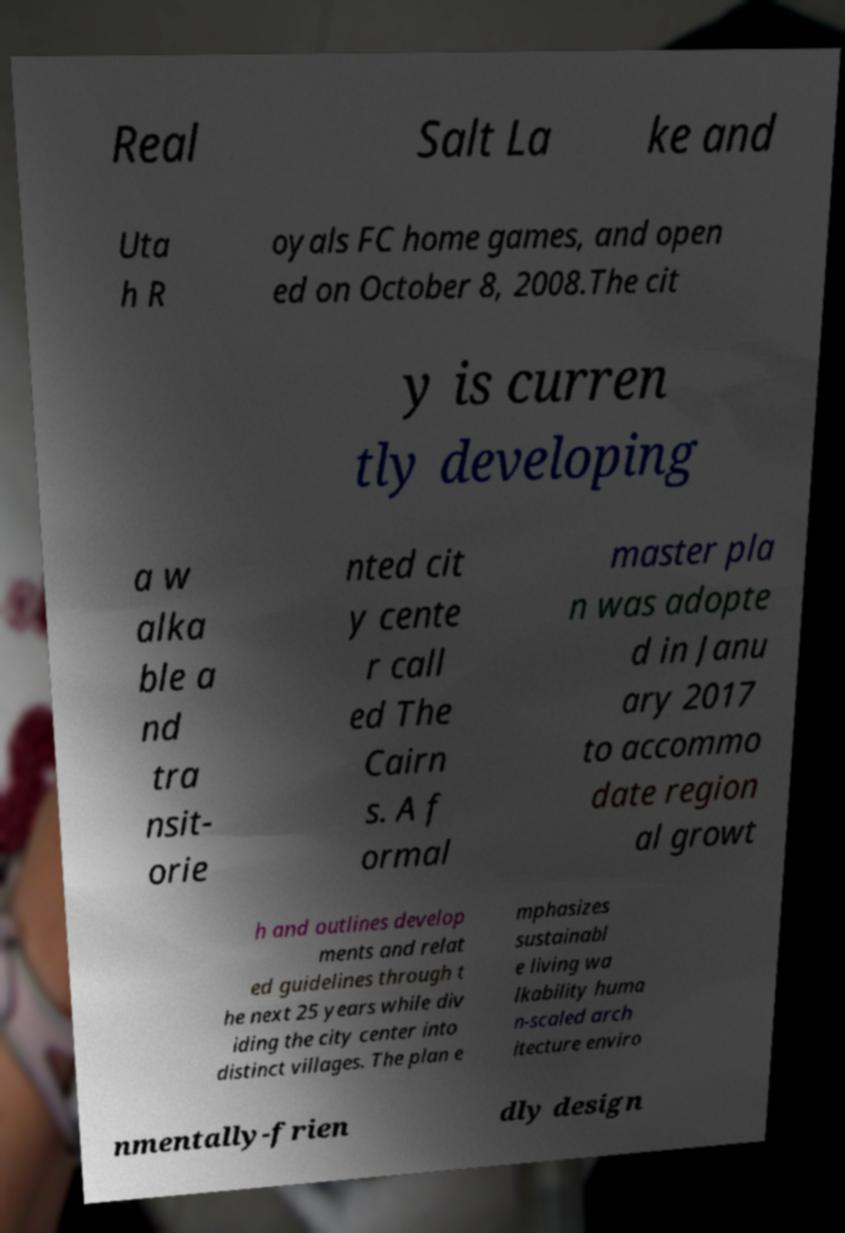For documentation purposes, I need the text within this image transcribed. Could you provide that? Real Salt La ke and Uta h R oyals FC home games, and open ed on October 8, 2008.The cit y is curren tly developing a w alka ble a nd tra nsit- orie nted cit y cente r call ed The Cairn s. A f ormal master pla n was adopte d in Janu ary 2017 to accommo date region al growt h and outlines develop ments and relat ed guidelines through t he next 25 years while div iding the city center into distinct villages. The plan e mphasizes sustainabl e living wa lkability huma n-scaled arch itecture enviro nmentally-frien dly design 